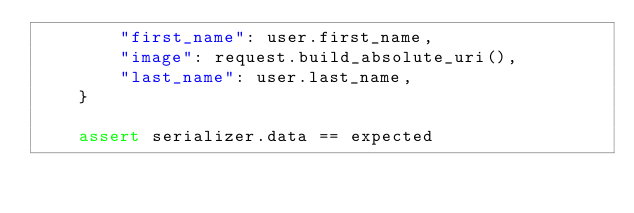<code> <loc_0><loc_0><loc_500><loc_500><_Python_>        "first_name": user.first_name,
        "image": request.build_absolute_uri(),
        "last_name": user.last_name,
    }

    assert serializer.data == expected
</code> 